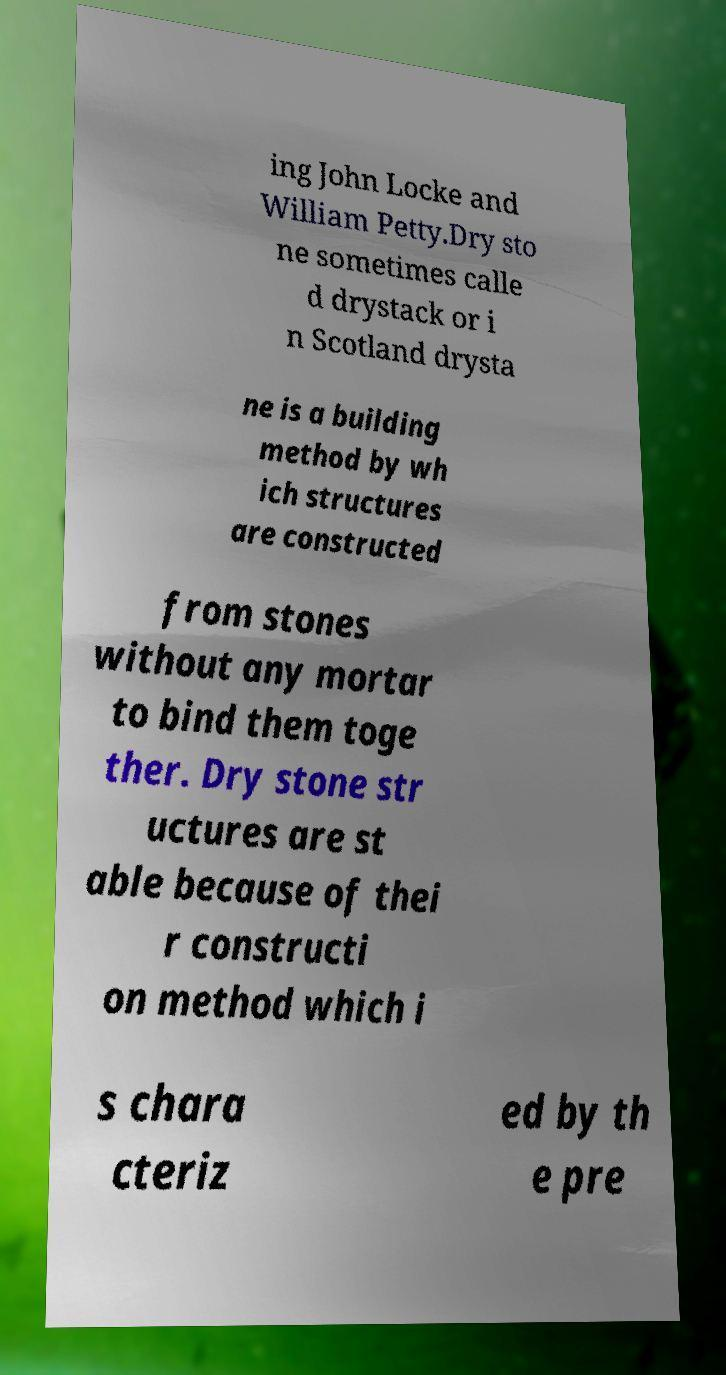Could you extract and type out the text from this image? ing John Locke and William Petty.Dry sto ne sometimes calle d drystack or i n Scotland drysta ne is a building method by wh ich structures are constructed from stones without any mortar to bind them toge ther. Dry stone str uctures are st able because of thei r constructi on method which i s chara cteriz ed by th e pre 